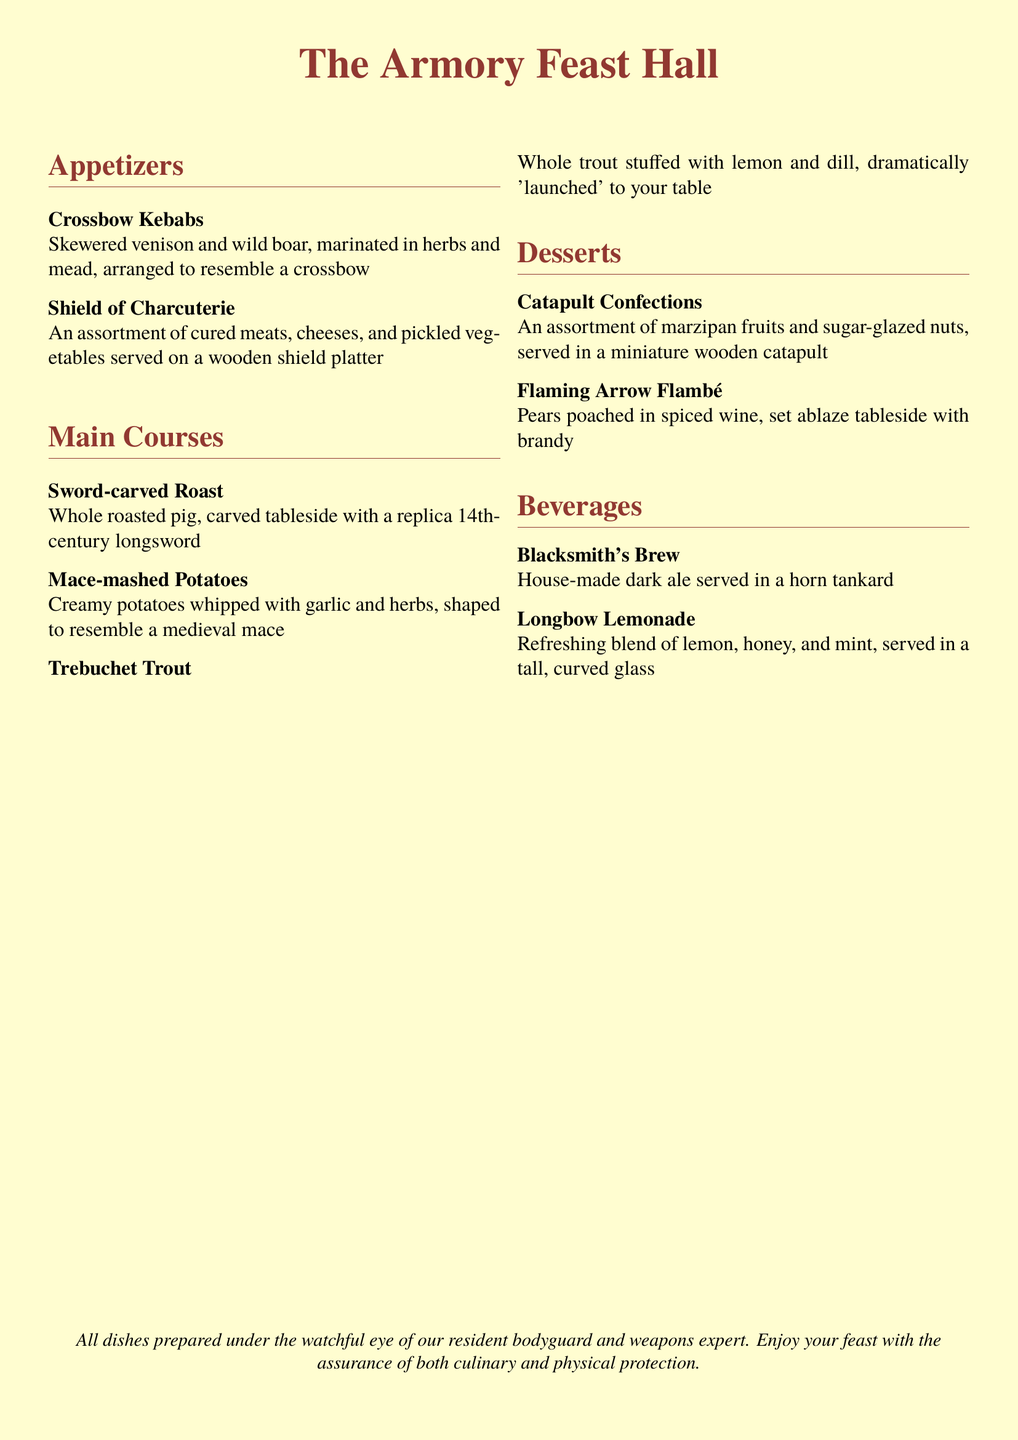What is the name of the main dish featuring a roasted pig? The main dish featuring a roasted pig is called "Sword-carved Roast".
Answer: Sword-carved Roast How are the Crossbow Kebabs described? The Crossbow Kebabs are skewered venison and wild boar, marinated in herbs and mead, arranged to resemble a crossbow.
Answer: Skewered venison and wild boar, marinated in herbs and mead, arranged to resemble a crossbow What unique method is used to serve the Trebuchet Trout? The Trebuchet Trout is dramatically 'launched' to your table.
Answer: Launched What beverage is served in a horn tankard? The beverage served in a horn tankard is called "Blacksmith's Brew".
Answer: Blacksmith's Brew How are the Mace-mashed Potatoes presented? The Mace-mashed Potatoes are shaped to resemble a medieval mace.
Answer: Resemble a medieval mace What type of fruit dessert is flambéed at the table? The type of fruit dessert flambéed at the table is "Pears poached in spiced wine".
Answer: Pears poached in spiced wine How is the Shield of Charcuterie presented? The Shield of Charcuterie is served on a wooden shield platter.
Answer: Wooden shield platter What type of lemonade is on the menu? The type of lemonade on the menu is "Longbow Lemonade".
Answer: Longbow Lemonade What is the font used in the menu? The font used in the menu is "TeX Gyre Termes".
Answer: TeX Gyre Termes 